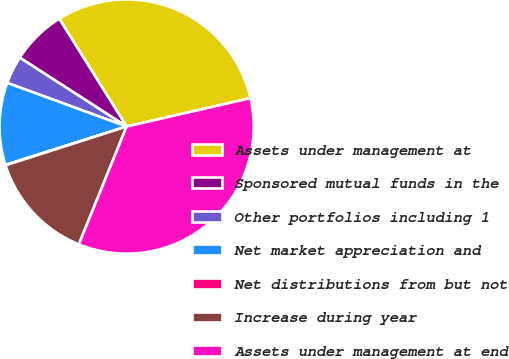Convert chart. <chart><loc_0><loc_0><loc_500><loc_500><pie_chart><fcel>Assets under management at<fcel>Sponsored mutual funds in the<fcel>Other portfolios including 1<fcel>Net market appreciation and<fcel>Net distributions from but not<fcel>Increase during year<fcel>Assets under management at end<nl><fcel>30.3%<fcel>7.0%<fcel>3.53%<fcel>10.46%<fcel>0.06%<fcel>13.93%<fcel>34.72%<nl></chart> 